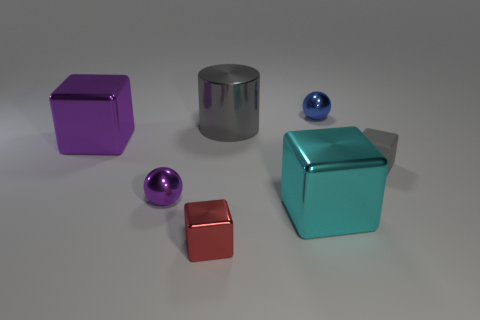Subtract all blue blocks. Subtract all blue balls. How many blocks are left? 4 Add 2 tiny blue metal objects. How many objects exist? 9 Subtract all cylinders. How many objects are left? 6 Subtract all big things. Subtract all tiny red cubes. How many objects are left? 3 Add 3 red shiny cubes. How many red shiny cubes are left? 4 Add 7 small yellow shiny balls. How many small yellow shiny balls exist? 7 Subtract 0 green balls. How many objects are left? 7 